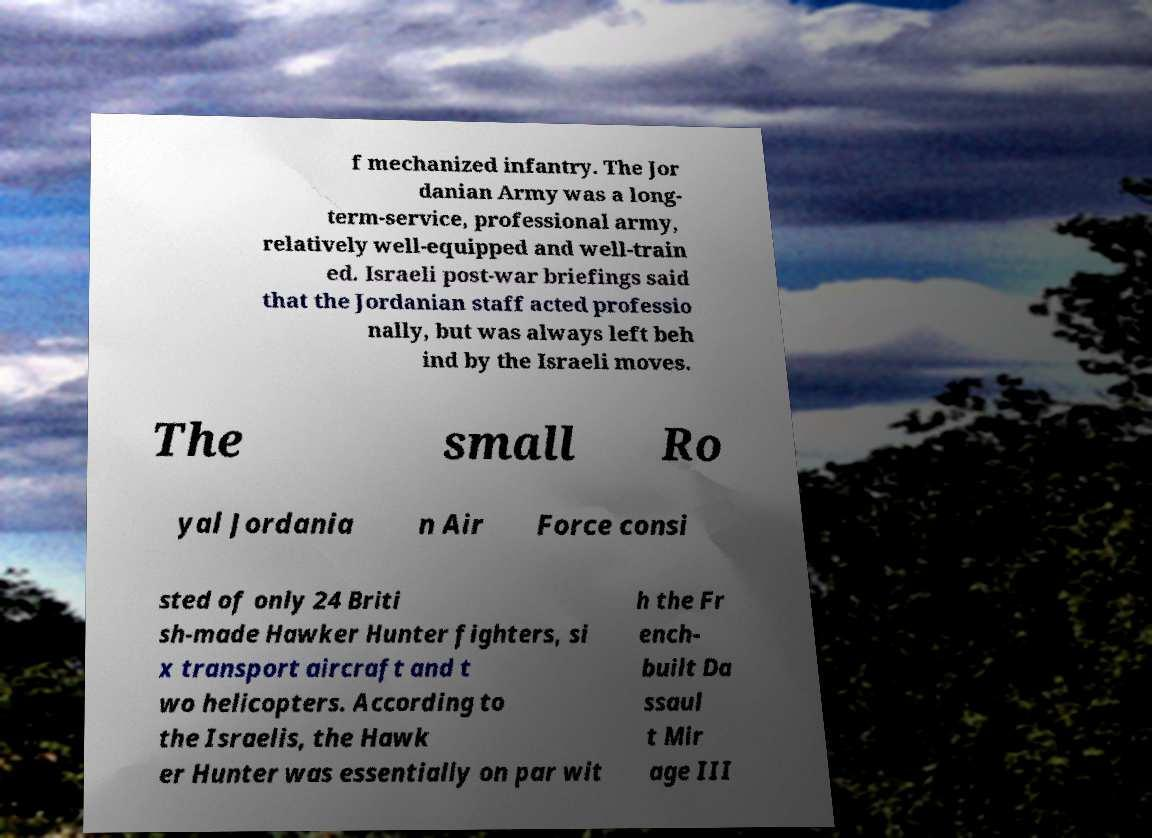Can you read and provide the text displayed in the image?This photo seems to have some interesting text. Can you extract and type it out for me? f mechanized infantry. The Jor danian Army was a long- term-service, professional army, relatively well-equipped and well-train ed. Israeli post-war briefings said that the Jordanian staff acted professio nally, but was always left beh ind by the Israeli moves. The small Ro yal Jordania n Air Force consi sted of only 24 Briti sh-made Hawker Hunter fighters, si x transport aircraft and t wo helicopters. According to the Israelis, the Hawk er Hunter was essentially on par wit h the Fr ench- built Da ssaul t Mir age III 